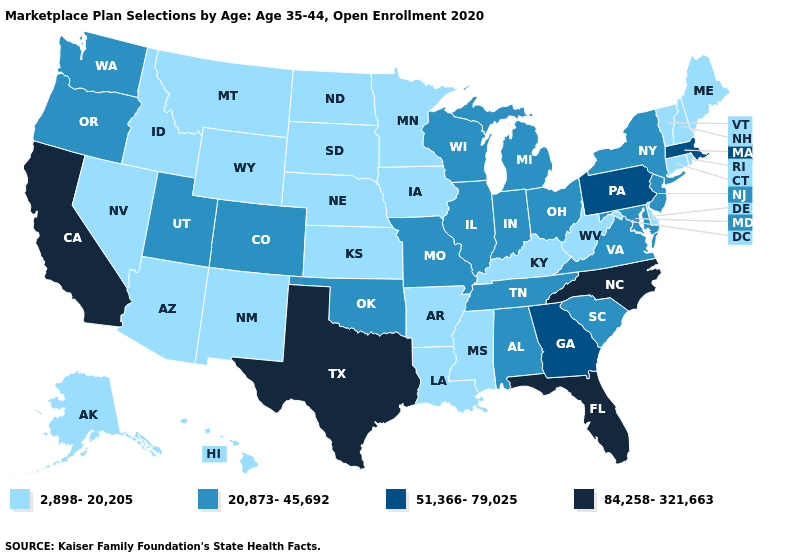Among the states that border Vermont , which have the highest value?
Keep it brief. Massachusetts. What is the value of Kansas?
Answer briefly. 2,898-20,205. Does the map have missing data?
Give a very brief answer. No. Does Oklahoma have a lower value than Arkansas?
Be succinct. No. Which states have the lowest value in the USA?
Write a very short answer. Alaska, Arizona, Arkansas, Connecticut, Delaware, Hawaii, Idaho, Iowa, Kansas, Kentucky, Louisiana, Maine, Minnesota, Mississippi, Montana, Nebraska, Nevada, New Hampshire, New Mexico, North Dakota, Rhode Island, South Dakota, Vermont, West Virginia, Wyoming. Does Texas have a lower value than Kansas?
Answer briefly. No. Which states have the highest value in the USA?
Write a very short answer. California, Florida, North Carolina, Texas. Name the states that have a value in the range 84,258-321,663?
Write a very short answer. California, Florida, North Carolina, Texas. What is the value of Oklahoma?
Write a very short answer. 20,873-45,692. Name the states that have a value in the range 20,873-45,692?
Give a very brief answer. Alabama, Colorado, Illinois, Indiana, Maryland, Michigan, Missouri, New Jersey, New York, Ohio, Oklahoma, Oregon, South Carolina, Tennessee, Utah, Virginia, Washington, Wisconsin. What is the value of Oregon?
Write a very short answer. 20,873-45,692. Name the states that have a value in the range 84,258-321,663?
Write a very short answer. California, Florida, North Carolina, Texas. Name the states that have a value in the range 2,898-20,205?
Answer briefly. Alaska, Arizona, Arkansas, Connecticut, Delaware, Hawaii, Idaho, Iowa, Kansas, Kentucky, Louisiana, Maine, Minnesota, Mississippi, Montana, Nebraska, Nevada, New Hampshire, New Mexico, North Dakota, Rhode Island, South Dakota, Vermont, West Virginia, Wyoming. Among the states that border Utah , does New Mexico have the highest value?
Answer briefly. No. 